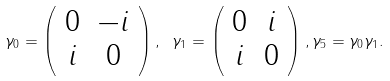<formula> <loc_0><loc_0><loc_500><loc_500>\gamma _ { 0 } = \left ( \begin{array} { c c } 0 & - i \\ i & 0 \end{array} \right ) , \text { } \gamma _ { 1 } = \left ( \begin{array} { c c } 0 & i \\ i & 0 \end{array} \right ) , \gamma _ { 5 } = \gamma _ { 0 } \gamma _ { 1 } .</formula> 